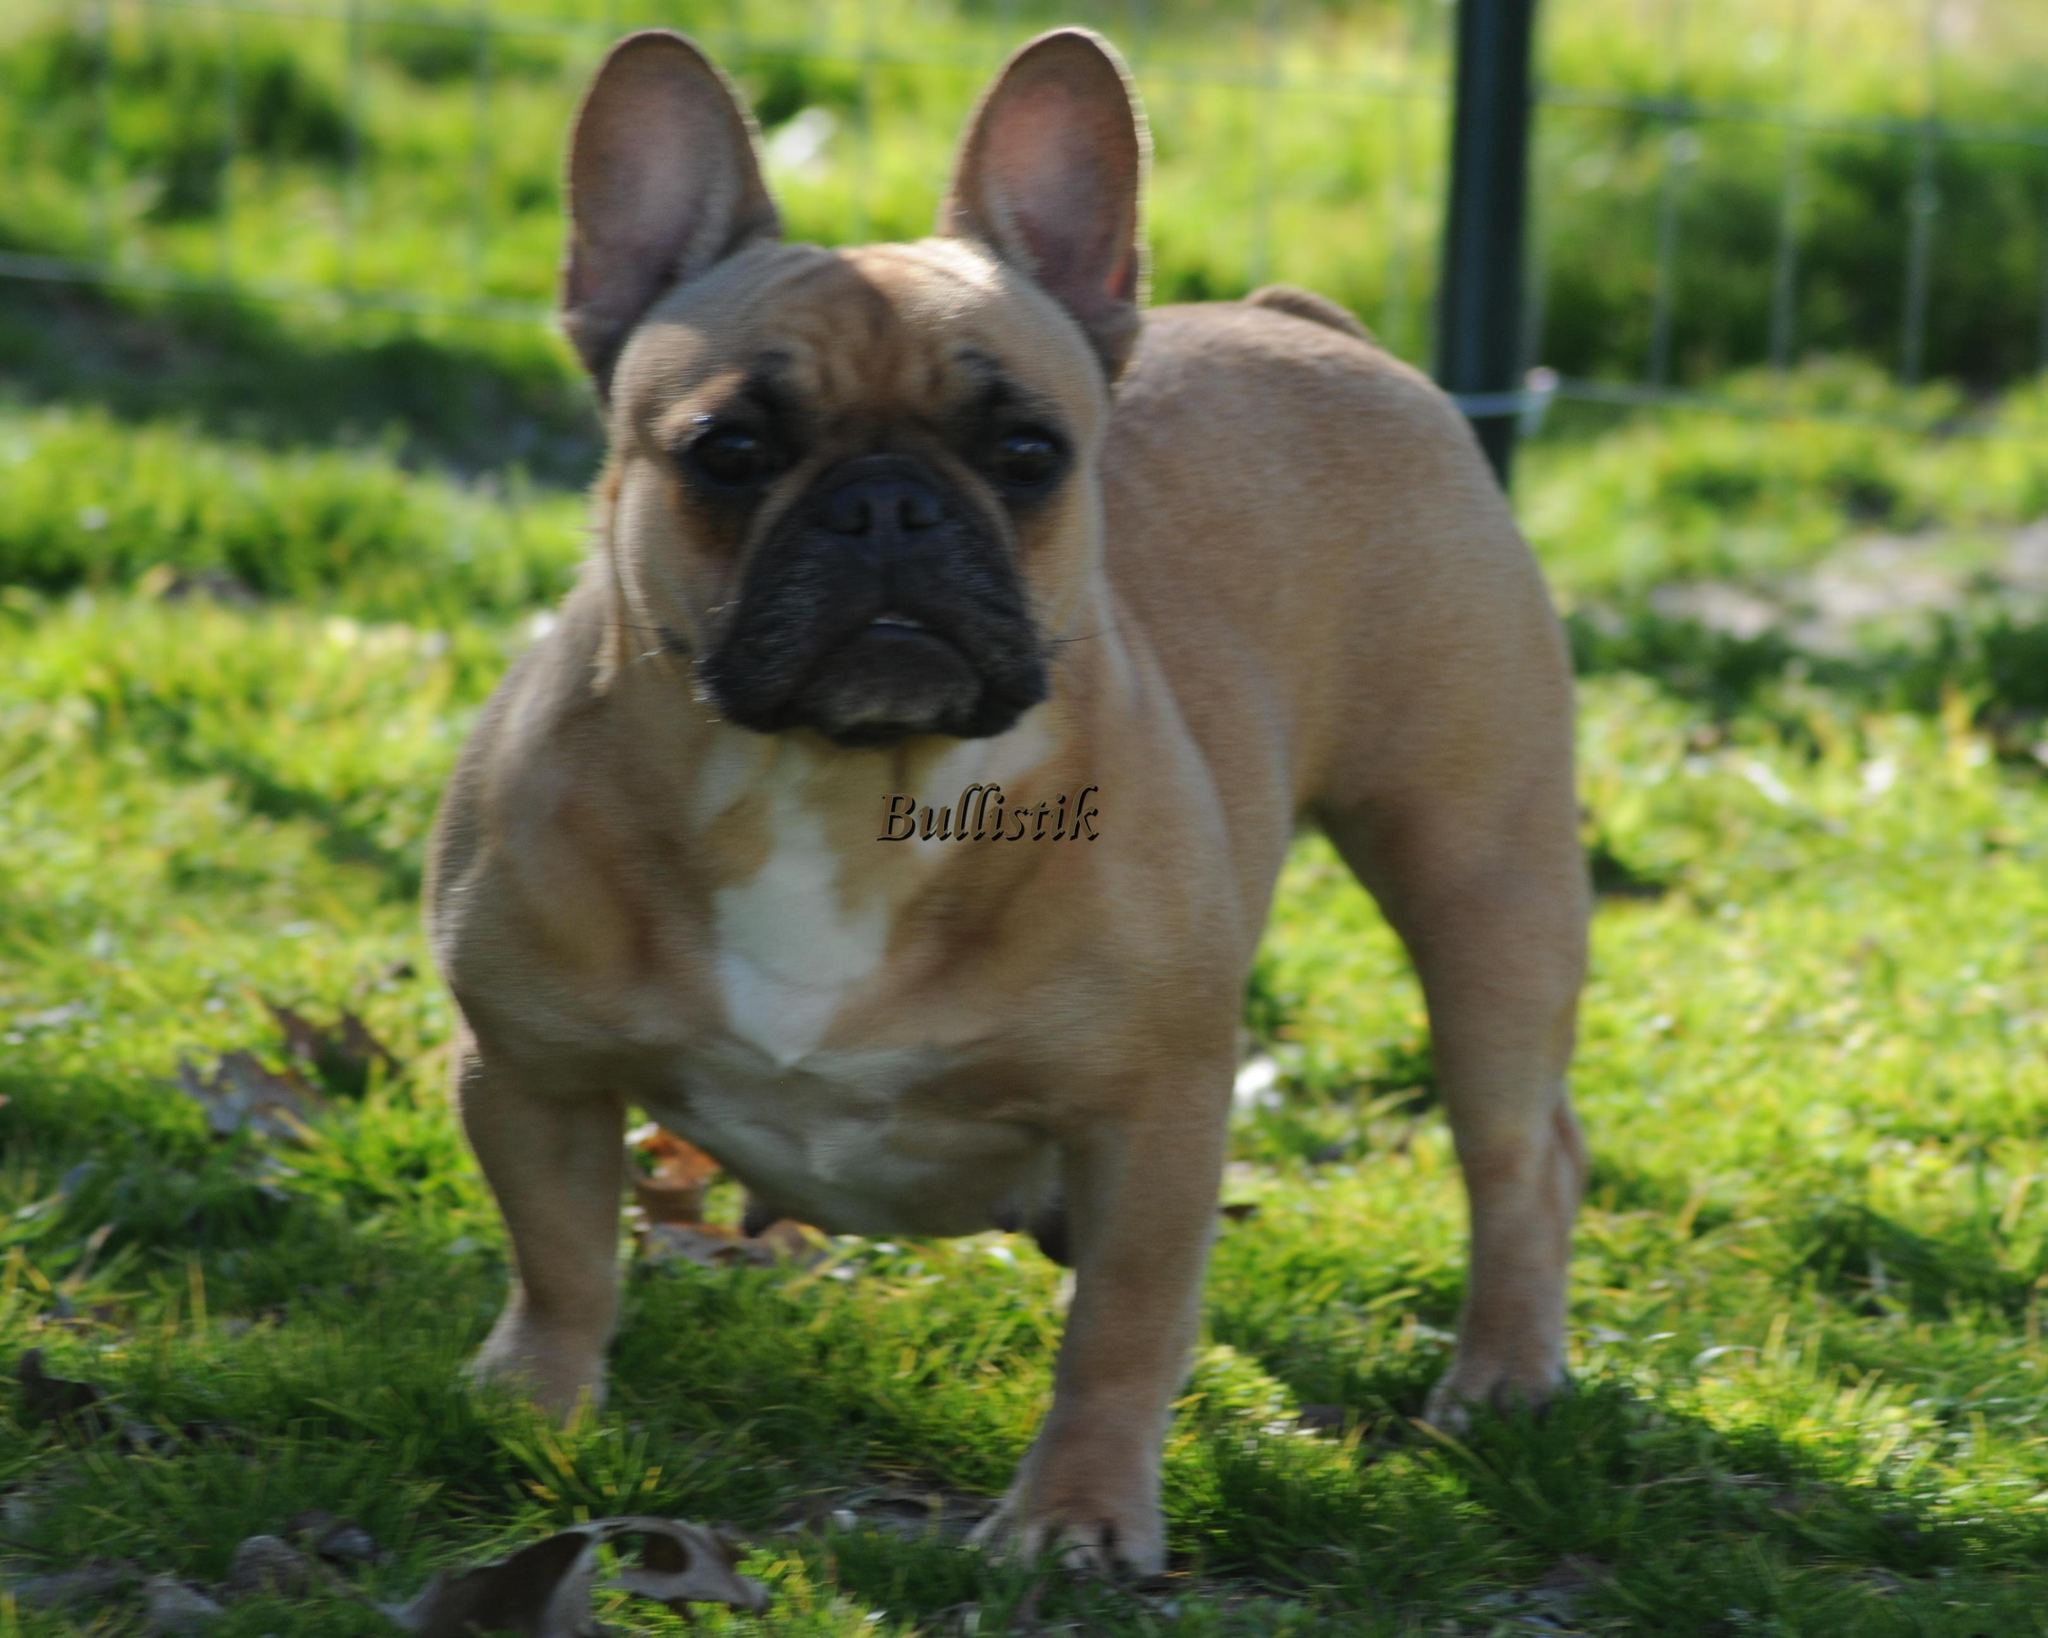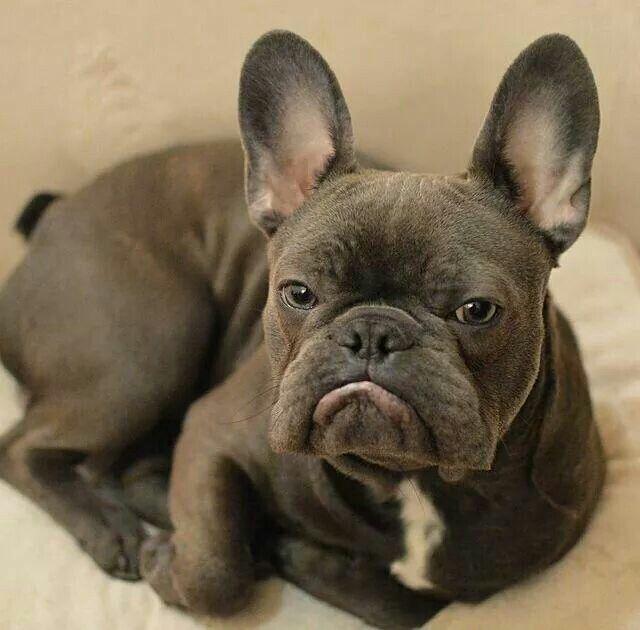The first image is the image on the left, the second image is the image on the right. Analyze the images presented: Is the assertion "At least one big-eared bulldog is standing on all fours on green grass, facing toward the camera." valid? Answer yes or no. Yes. The first image is the image on the left, the second image is the image on the right. For the images shown, is this caption "The dog in the image on the left is inside." true? Answer yes or no. No. 